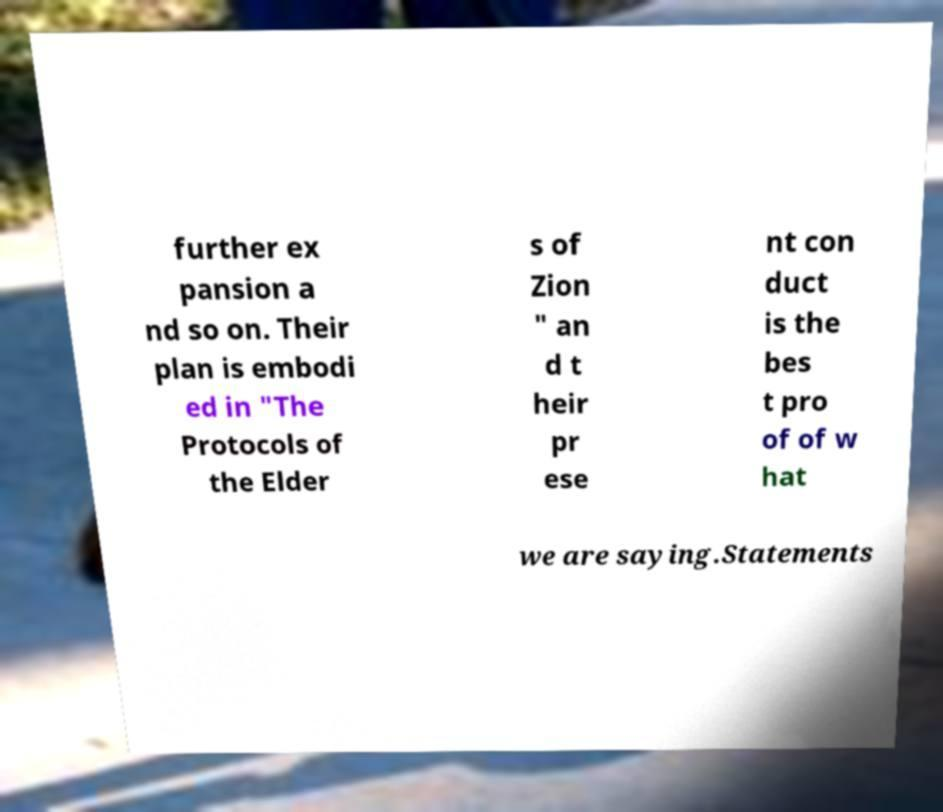What messages or text are displayed in this image? I need them in a readable, typed format. further ex pansion a nd so on. Their plan is embodi ed in "The Protocols of the Elder s of Zion " an d t heir pr ese nt con duct is the bes t pro of of w hat we are saying.Statements 